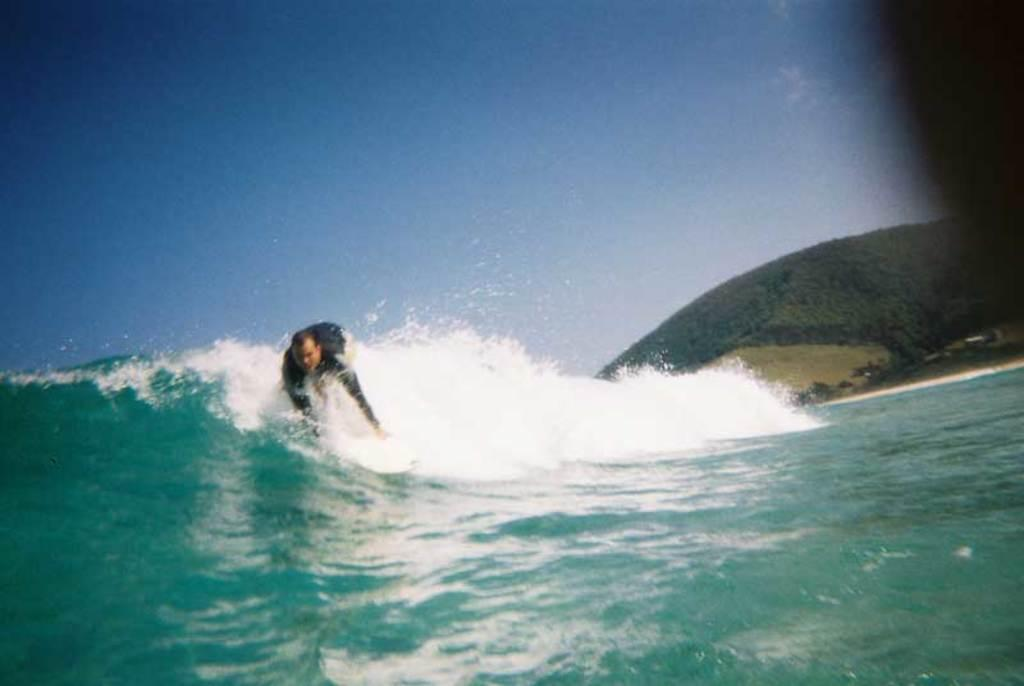Who is the person in the image? There is a man in the image. What is the man doing in the image? The man is surfing on the water surface. What can be seen in the background of the image? There are trees and hills in the background of the image. What is the condition of the sky in the image? The sky is clear in the image. What type of friction is the man experiencing while surfing in the image? The provided facts do not mention any details about the friction experienced by the man while surfing. --- Facts: 1. There is a group of people in the image. 2. The people are wearing hats. 3. The people are holding hands. 4. There is a river in the background of the image. 5. There are trees on the riverbank. Absurd Topics: parrot, dance, fire Conversation: How many people are in the image? There is a group of people in the image. What are the people wearing in the image? The people are wearing hats. What are the people doing in the image? The people are holding hands. What can be seen in the background of the image? There is a river and trees on the riverbank in the background of the image. Reasoning: Let's think step by step in order to produce the conversation. We start by identifying the main subject in the image, which is the group of people. Then, we describe what the people are wearing, which are hats. Next, we mention what the people are doing, which is holding hands. Finally, we expand the conversation to include the background of the image, which features a river and trees on the riverbank. Absurd Question/Answer: What type of dance is the parrot performing in the image? There is no parrot present in the image, so it cannot be determined if a parrot is performing any dance. 